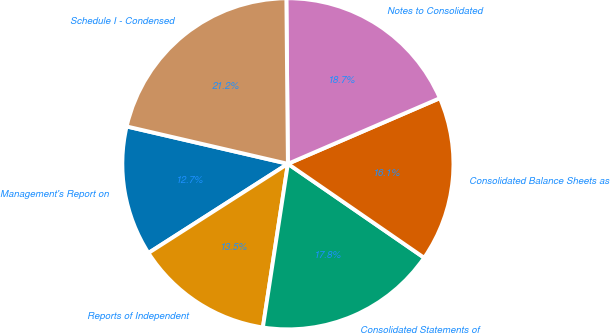Convert chart to OTSL. <chart><loc_0><loc_0><loc_500><loc_500><pie_chart><fcel>Management's Report on<fcel>Reports of Independent<fcel>Consolidated Statements of<fcel>Consolidated Balance Sheets as<fcel>Notes to Consolidated<fcel>Schedule I - Condensed<nl><fcel>12.68%<fcel>13.53%<fcel>17.81%<fcel>16.1%<fcel>18.66%<fcel>21.23%<nl></chart> 